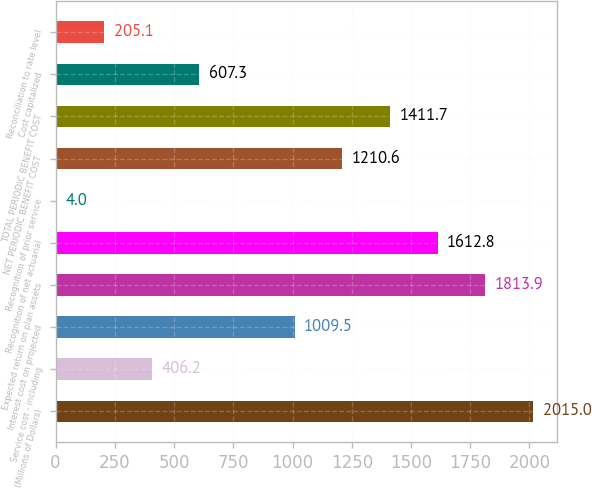<chart> <loc_0><loc_0><loc_500><loc_500><bar_chart><fcel>(Millions of Dollars)<fcel>Service cost - including<fcel>Interest cost on projected<fcel>Expected return on plan assets<fcel>Recognition of net actuarial<fcel>Recognition of prior service<fcel>NET PERIODIC BENEFIT COST<fcel>TOTAL PERIODIC BENEFIT COST<fcel>Cost capitalized<fcel>Reconciliation to rate level<nl><fcel>2015<fcel>406.2<fcel>1009.5<fcel>1813.9<fcel>1612.8<fcel>4<fcel>1210.6<fcel>1411.7<fcel>607.3<fcel>205.1<nl></chart> 